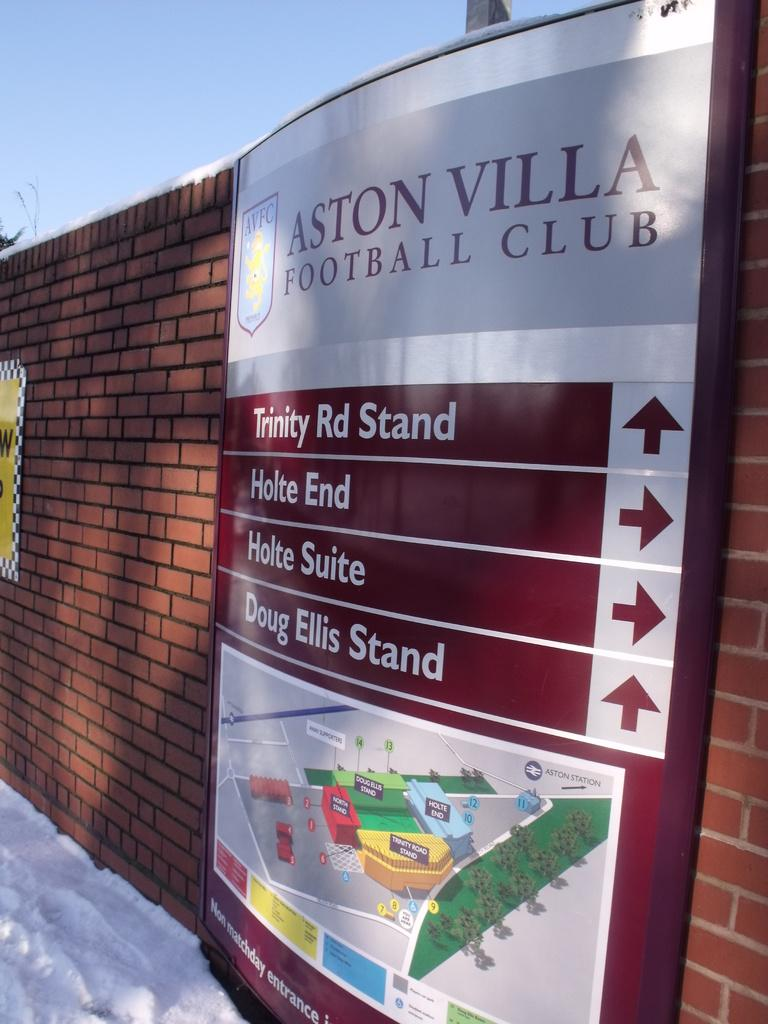Provide a one-sentence caption for the provided image. a sign at the aston vila football club showing direction to different parts of the club. 